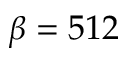Convert formula to latex. <formula><loc_0><loc_0><loc_500><loc_500>\beta = 5 1 2</formula> 